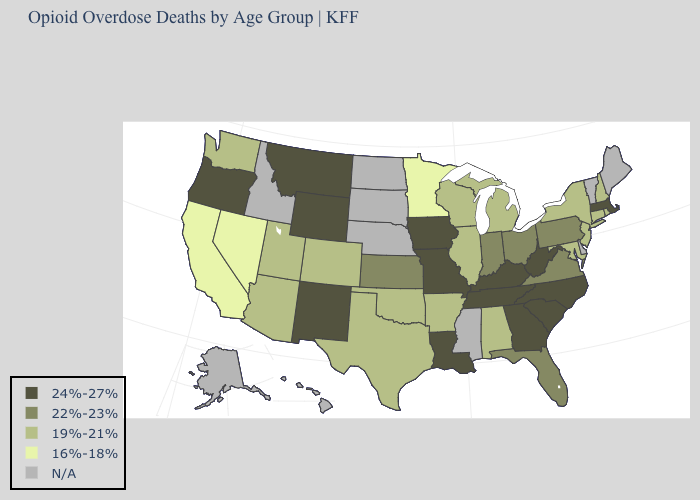What is the lowest value in states that border Idaho?
Write a very short answer. 16%-18%. Name the states that have a value in the range 24%-27%?
Concise answer only. Georgia, Iowa, Kentucky, Louisiana, Massachusetts, Missouri, Montana, New Mexico, North Carolina, Oregon, South Carolina, Tennessee, West Virginia, Wyoming. Name the states that have a value in the range 16%-18%?
Keep it brief. California, Minnesota, Nevada. Does Kentucky have the highest value in the USA?
Be succinct. Yes. What is the value of New Mexico?
Write a very short answer. 24%-27%. Which states hav the highest value in the South?
Write a very short answer. Georgia, Kentucky, Louisiana, North Carolina, South Carolina, Tennessee, West Virginia. Name the states that have a value in the range 19%-21%?
Give a very brief answer. Alabama, Arizona, Arkansas, Colorado, Connecticut, Illinois, Maryland, Michigan, New Hampshire, New Jersey, New York, Oklahoma, Rhode Island, Texas, Utah, Washington, Wisconsin. Does California have the lowest value in the West?
Quick response, please. Yes. What is the highest value in the USA?
Concise answer only. 24%-27%. Which states have the lowest value in the West?
Quick response, please. California, Nevada. What is the lowest value in the USA?
Keep it brief. 16%-18%. Name the states that have a value in the range 24%-27%?
Concise answer only. Georgia, Iowa, Kentucky, Louisiana, Massachusetts, Missouri, Montana, New Mexico, North Carolina, Oregon, South Carolina, Tennessee, West Virginia, Wyoming. 